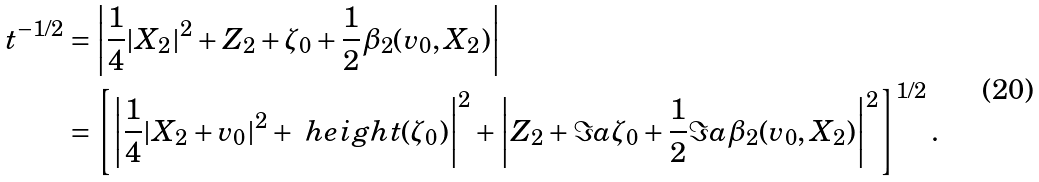<formula> <loc_0><loc_0><loc_500><loc_500>t ^ { - 1 / 2 } & = \left | \frac { 1 } { 4 } | X _ { 2 } | ^ { 2 } + Z _ { 2 } + \zeta _ { 0 } + \frac { 1 } { 2 } \beta _ { 2 } ( v _ { 0 } , X _ { 2 } ) \right | \\ & = \left [ \left | \frac { 1 } { 4 } | X _ { 2 } + v _ { 0 } | ^ { 2 } + \ h e i g h t ( \zeta _ { 0 } ) \right | ^ { 2 } + \left | Z _ { 2 } + \Im a \zeta _ { 0 } + \frac { 1 } { 2 } \Im a \beta _ { 2 } ( v _ { 0 } , X _ { 2 } ) \right | ^ { 2 } \right ] ^ { 1 / 2 } .</formula> 